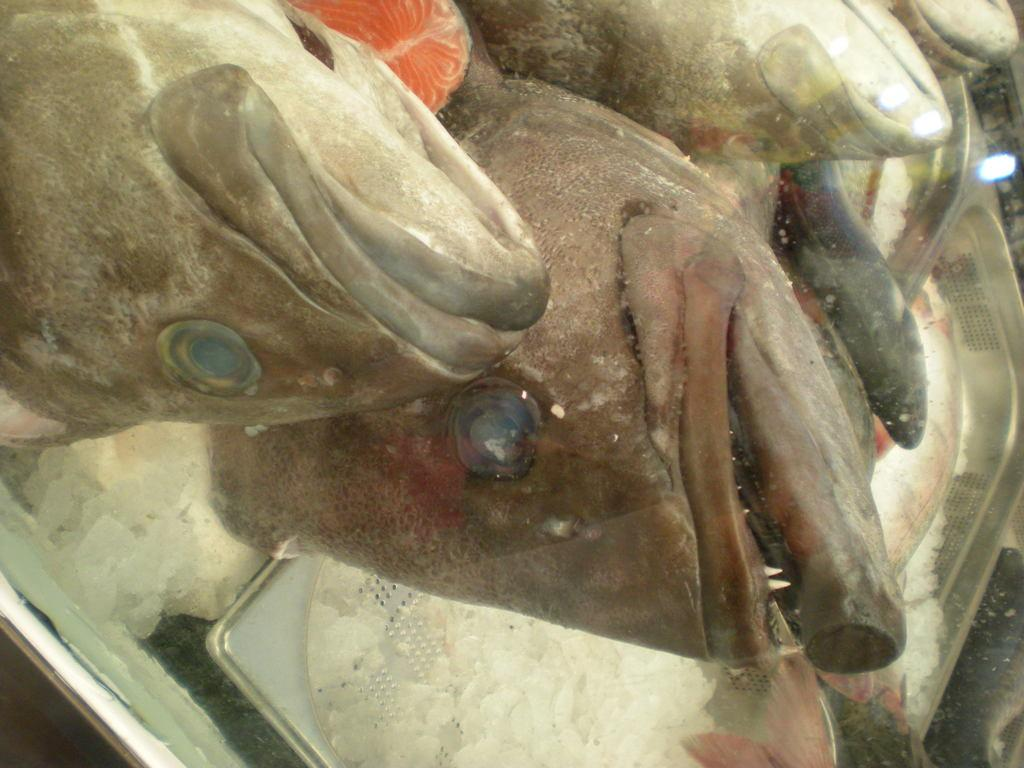Where was the image taken? The image was taken indoors. What can be seen at the bottom of the image? There are trees with ice cubes in them at the bottom of the image. What is in the middle of the image? There are a few fishes and fish slices in the middle of the image. What type of mint is growing on the trees with ice cubes in the image? There is no mint growing on the trees with ice cubes in the image; the trees have ice cubes, not mint. What caused the fishes to be in the middle of the image? The provided facts do not mention a cause for the fishes being in the middle of the image; we can only describe what is present in the image. 